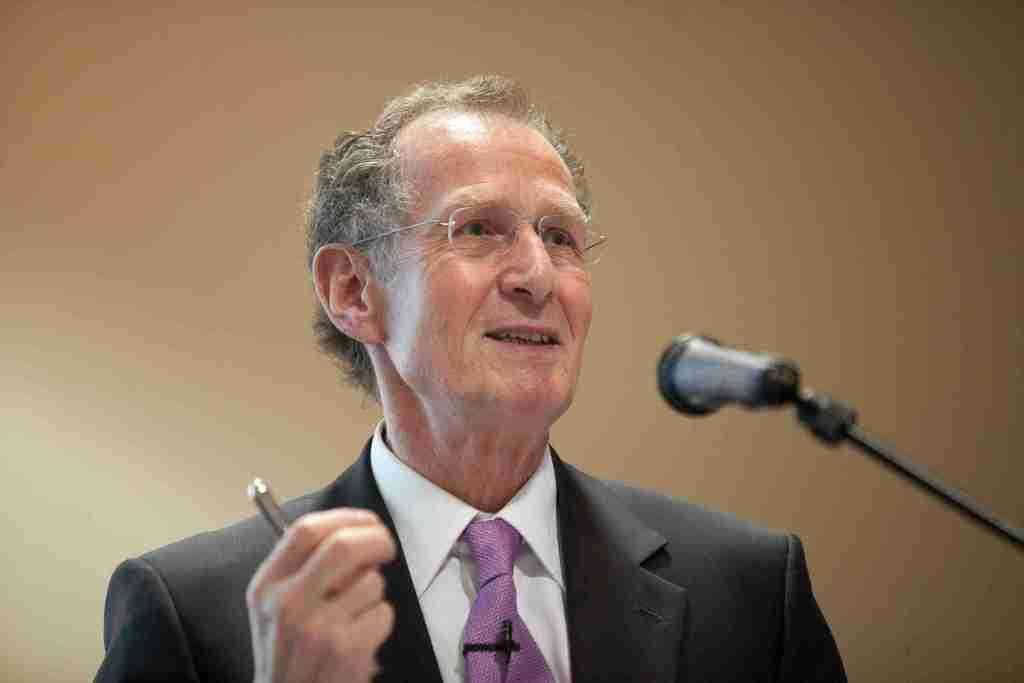Please provide a concise description of this image. In this picture we can see a person, he is wearing a spectacles, holding an object, in front of him we can see a mic and in the background we can see a surface. 